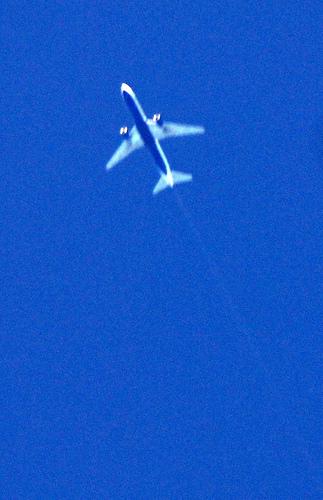For what purpose is the plane flying?
Keep it brief. Travel. What direction does the plane appear to be traveling?
Be succinct. Up. How many propellers are visible in this picture?
Give a very brief answer. 0. Are the landing gear up or down?
Concise answer only. Up. Are the clouds visible?
Be succinct. No. Is this an air show?
Quick response, please. No. Is it a cloudy day?
Keep it brief. No. Is this an action movie still?
Quick response, please. No. What color is the tip of the plane's tail?
Write a very short answer. White. Is this a commercial jet?
Short answer required. Yes. Is this a fighter jet?
Quick response, please. No. 